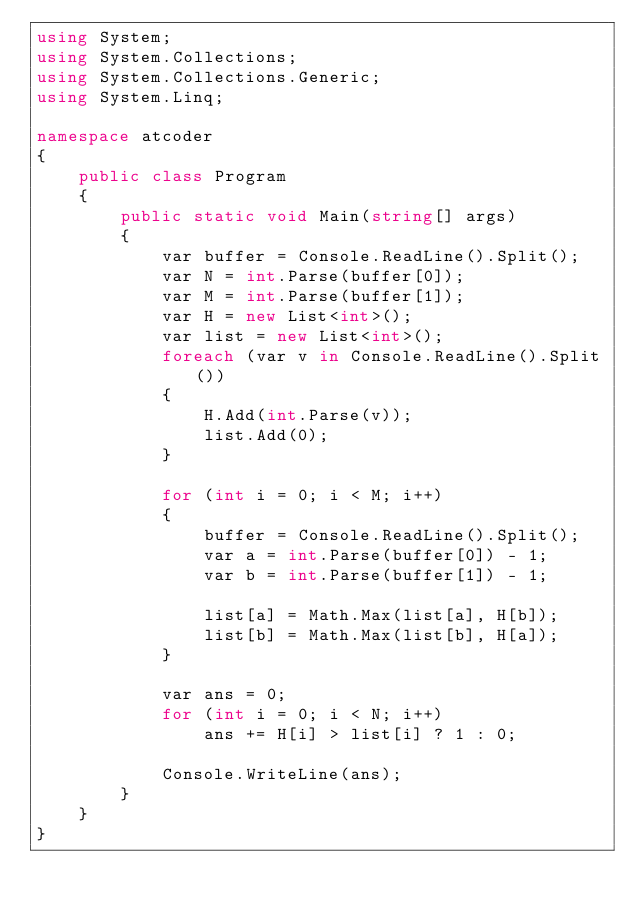<code> <loc_0><loc_0><loc_500><loc_500><_C#_>using System;
using System.Collections;
using System.Collections.Generic;
using System.Linq;

namespace atcoder
{
    public class Program
    {
        public static void Main(string[] args)
        {
            var buffer = Console.ReadLine().Split();
            var N = int.Parse(buffer[0]);
            var M = int.Parse(buffer[1]);
            var H = new List<int>();
            var list = new List<int>();
            foreach (var v in Console.ReadLine().Split())
            {
                H.Add(int.Parse(v));
                list.Add(0);
            }

            for (int i = 0; i < M; i++)
            {
                buffer = Console.ReadLine().Split();
                var a = int.Parse(buffer[0]) - 1;
                var b = int.Parse(buffer[1]) - 1;

                list[a] = Math.Max(list[a], H[b]);
                list[b] = Math.Max(list[b], H[a]);
            }

            var ans = 0;
            for (int i = 0; i < N; i++)
                ans += H[i] > list[i] ? 1 : 0;

            Console.WriteLine(ans);
        }
    }
}
</code> 